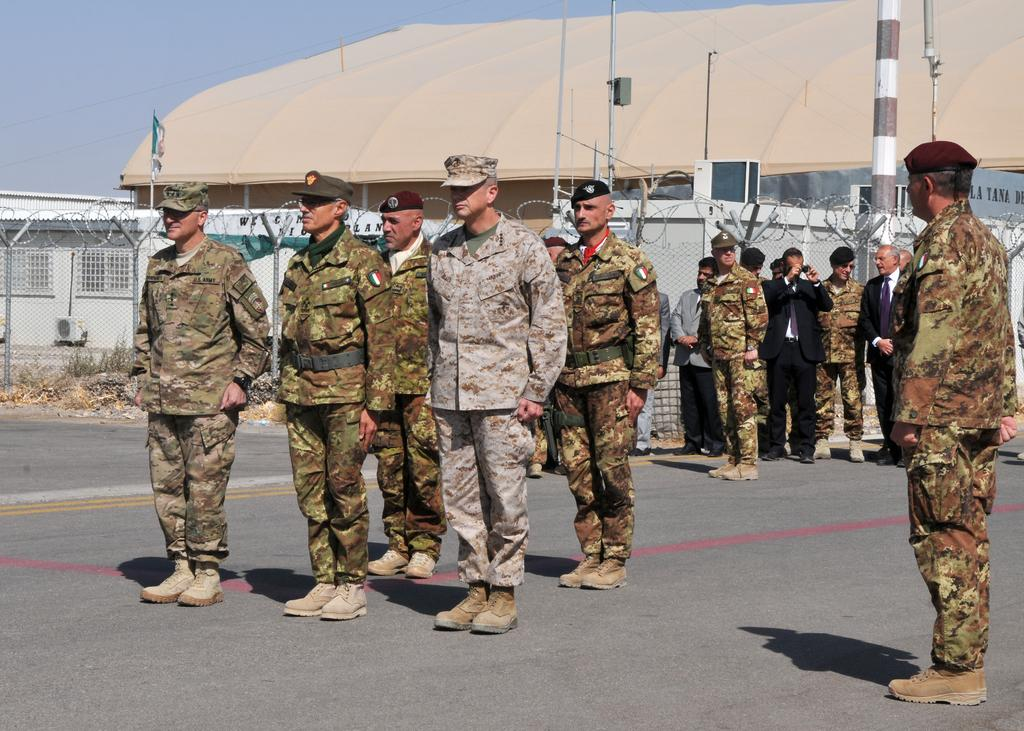What is happening on the road in the image? There is a group of people on the road in the image. What objects can be seen in the image besides the people? There are poles, a fence, a flag, and a shed in the image. What is visible in the background of the image? The sky is visible in the background of the image. Can you see a snail climbing up the flagpole in the image? There is no snail present in the image, and therefore no such activity can be observed. 